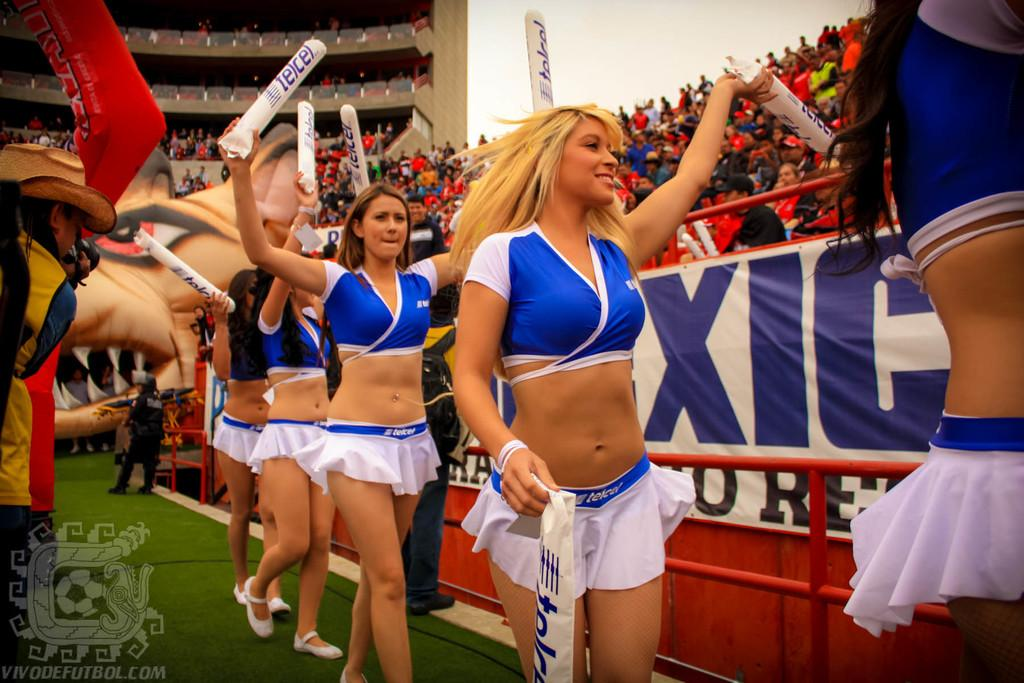<image>
Summarize the visual content of the image. Cheerleaders holding up white rods that say telcel 